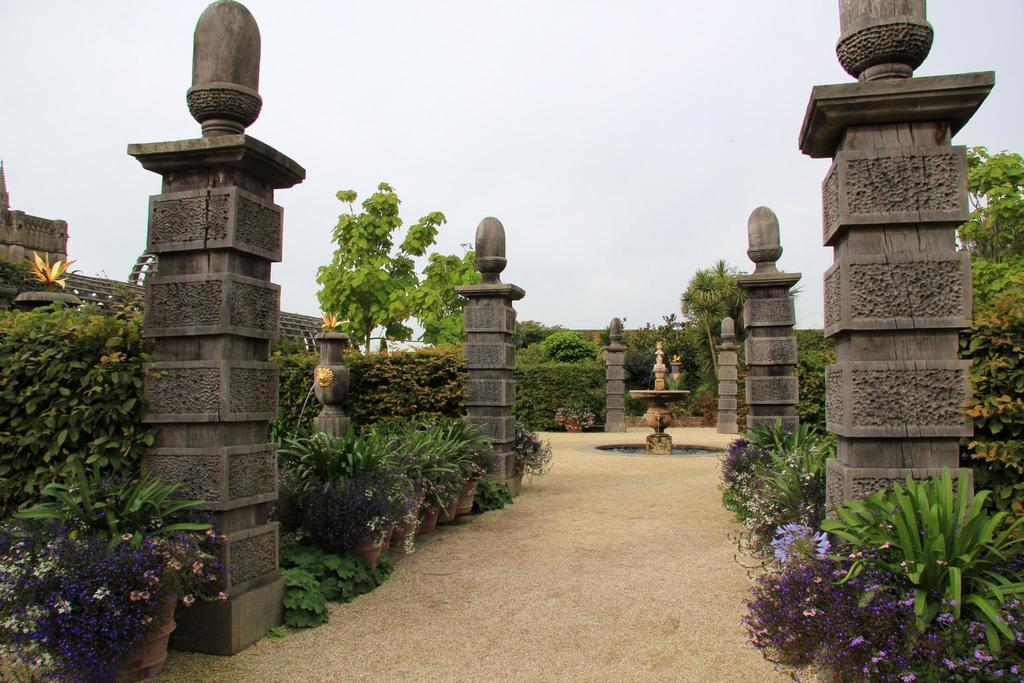How would you summarize this image in a sentence or two? In the picture there are many pillars present, there are many trees, there are plants, there is a fountain, there is a clear sky. 